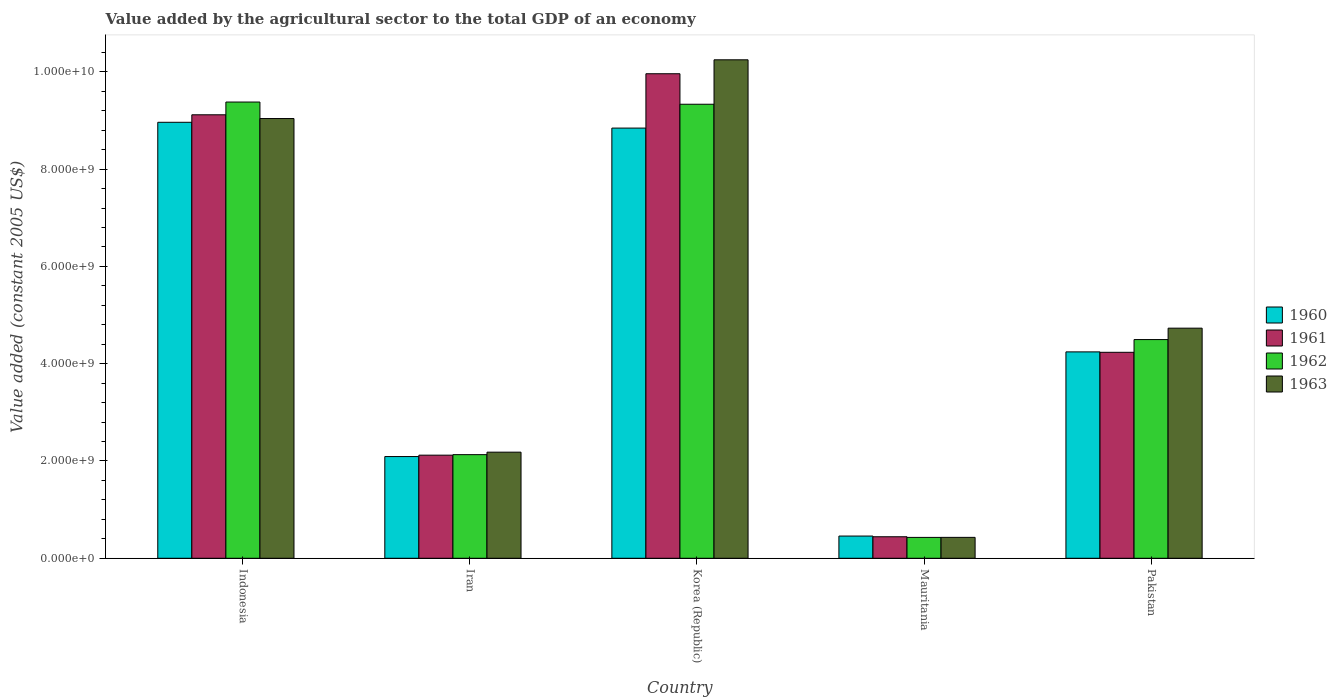How many different coloured bars are there?
Ensure brevity in your answer.  4. How many groups of bars are there?
Provide a succinct answer. 5. How many bars are there on the 5th tick from the left?
Your answer should be compact. 4. How many bars are there on the 2nd tick from the right?
Ensure brevity in your answer.  4. What is the label of the 4th group of bars from the left?
Provide a succinct answer. Mauritania. What is the value added by the agricultural sector in 1960 in Pakistan?
Offer a very short reply. 4.24e+09. Across all countries, what is the maximum value added by the agricultural sector in 1962?
Your answer should be compact. 9.38e+09. Across all countries, what is the minimum value added by the agricultural sector in 1962?
Keep it short and to the point. 4.29e+08. In which country was the value added by the agricultural sector in 1961 maximum?
Keep it short and to the point. Korea (Republic). In which country was the value added by the agricultural sector in 1962 minimum?
Keep it short and to the point. Mauritania. What is the total value added by the agricultural sector in 1962 in the graph?
Your answer should be very brief. 2.58e+1. What is the difference between the value added by the agricultural sector in 1963 in Korea (Republic) and that in Mauritania?
Your answer should be very brief. 9.82e+09. What is the difference between the value added by the agricultural sector in 1962 in Pakistan and the value added by the agricultural sector in 1961 in Iran?
Ensure brevity in your answer.  2.38e+09. What is the average value added by the agricultural sector in 1961 per country?
Make the answer very short. 5.17e+09. What is the difference between the value added by the agricultural sector of/in 1962 and value added by the agricultural sector of/in 1961 in Mauritania?
Make the answer very short. -1.31e+07. What is the ratio of the value added by the agricultural sector in 1960 in Iran to that in Mauritania?
Offer a terse response. 4.58. What is the difference between the highest and the second highest value added by the agricultural sector in 1962?
Offer a terse response. -4.52e+07. What is the difference between the highest and the lowest value added by the agricultural sector in 1960?
Provide a succinct answer. 8.51e+09. In how many countries, is the value added by the agricultural sector in 1963 greater than the average value added by the agricultural sector in 1963 taken over all countries?
Provide a succinct answer. 2. What does the 2nd bar from the right in Iran represents?
Provide a succinct answer. 1962. Are all the bars in the graph horizontal?
Make the answer very short. No. Does the graph contain any zero values?
Provide a short and direct response. No. Does the graph contain grids?
Your answer should be compact. No. How are the legend labels stacked?
Your answer should be compact. Vertical. What is the title of the graph?
Your answer should be very brief. Value added by the agricultural sector to the total GDP of an economy. What is the label or title of the X-axis?
Ensure brevity in your answer.  Country. What is the label or title of the Y-axis?
Your answer should be compact. Value added (constant 2005 US$). What is the Value added (constant 2005 US$) in 1960 in Indonesia?
Your answer should be very brief. 8.96e+09. What is the Value added (constant 2005 US$) of 1961 in Indonesia?
Offer a terse response. 9.12e+09. What is the Value added (constant 2005 US$) of 1962 in Indonesia?
Make the answer very short. 9.38e+09. What is the Value added (constant 2005 US$) of 1963 in Indonesia?
Provide a short and direct response. 9.04e+09. What is the Value added (constant 2005 US$) in 1960 in Iran?
Offer a terse response. 2.09e+09. What is the Value added (constant 2005 US$) in 1961 in Iran?
Make the answer very short. 2.12e+09. What is the Value added (constant 2005 US$) in 1962 in Iran?
Ensure brevity in your answer.  2.13e+09. What is the Value added (constant 2005 US$) in 1963 in Iran?
Ensure brevity in your answer.  2.18e+09. What is the Value added (constant 2005 US$) in 1960 in Korea (Republic)?
Provide a short and direct response. 8.84e+09. What is the Value added (constant 2005 US$) in 1961 in Korea (Republic)?
Give a very brief answer. 9.96e+09. What is the Value added (constant 2005 US$) in 1962 in Korea (Republic)?
Give a very brief answer. 9.33e+09. What is the Value added (constant 2005 US$) in 1963 in Korea (Republic)?
Offer a terse response. 1.02e+1. What is the Value added (constant 2005 US$) in 1960 in Mauritania?
Offer a terse response. 4.57e+08. What is the Value added (constant 2005 US$) in 1961 in Mauritania?
Keep it short and to the point. 4.42e+08. What is the Value added (constant 2005 US$) in 1962 in Mauritania?
Provide a succinct answer. 4.29e+08. What is the Value added (constant 2005 US$) in 1963 in Mauritania?
Make the answer very short. 4.30e+08. What is the Value added (constant 2005 US$) of 1960 in Pakistan?
Provide a succinct answer. 4.24e+09. What is the Value added (constant 2005 US$) in 1961 in Pakistan?
Your answer should be compact. 4.23e+09. What is the Value added (constant 2005 US$) in 1962 in Pakistan?
Provide a succinct answer. 4.50e+09. What is the Value added (constant 2005 US$) of 1963 in Pakistan?
Offer a terse response. 4.73e+09. Across all countries, what is the maximum Value added (constant 2005 US$) in 1960?
Ensure brevity in your answer.  8.96e+09. Across all countries, what is the maximum Value added (constant 2005 US$) in 1961?
Provide a short and direct response. 9.96e+09. Across all countries, what is the maximum Value added (constant 2005 US$) of 1962?
Your answer should be compact. 9.38e+09. Across all countries, what is the maximum Value added (constant 2005 US$) in 1963?
Keep it short and to the point. 1.02e+1. Across all countries, what is the minimum Value added (constant 2005 US$) in 1960?
Offer a very short reply. 4.57e+08. Across all countries, what is the minimum Value added (constant 2005 US$) of 1961?
Offer a terse response. 4.42e+08. Across all countries, what is the minimum Value added (constant 2005 US$) of 1962?
Keep it short and to the point. 4.29e+08. Across all countries, what is the minimum Value added (constant 2005 US$) in 1963?
Offer a very short reply. 4.30e+08. What is the total Value added (constant 2005 US$) of 1960 in the graph?
Provide a short and direct response. 2.46e+1. What is the total Value added (constant 2005 US$) of 1961 in the graph?
Give a very brief answer. 2.59e+1. What is the total Value added (constant 2005 US$) of 1962 in the graph?
Provide a succinct answer. 2.58e+1. What is the total Value added (constant 2005 US$) in 1963 in the graph?
Ensure brevity in your answer.  2.66e+1. What is the difference between the Value added (constant 2005 US$) in 1960 in Indonesia and that in Iran?
Give a very brief answer. 6.87e+09. What is the difference between the Value added (constant 2005 US$) of 1961 in Indonesia and that in Iran?
Provide a short and direct response. 7.00e+09. What is the difference between the Value added (constant 2005 US$) in 1962 in Indonesia and that in Iran?
Ensure brevity in your answer.  7.25e+09. What is the difference between the Value added (constant 2005 US$) of 1963 in Indonesia and that in Iran?
Provide a short and direct response. 6.86e+09. What is the difference between the Value added (constant 2005 US$) of 1960 in Indonesia and that in Korea (Republic)?
Provide a succinct answer. 1.19e+08. What is the difference between the Value added (constant 2005 US$) in 1961 in Indonesia and that in Korea (Republic)?
Your answer should be very brief. -8.44e+08. What is the difference between the Value added (constant 2005 US$) in 1962 in Indonesia and that in Korea (Republic)?
Make the answer very short. 4.52e+07. What is the difference between the Value added (constant 2005 US$) in 1963 in Indonesia and that in Korea (Republic)?
Your answer should be very brief. -1.21e+09. What is the difference between the Value added (constant 2005 US$) in 1960 in Indonesia and that in Mauritania?
Your answer should be very brief. 8.51e+09. What is the difference between the Value added (constant 2005 US$) in 1961 in Indonesia and that in Mauritania?
Make the answer very short. 8.68e+09. What is the difference between the Value added (constant 2005 US$) of 1962 in Indonesia and that in Mauritania?
Your answer should be very brief. 8.95e+09. What is the difference between the Value added (constant 2005 US$) of 1963 in Indonesia and that in Mauritania?
Your response must be concise. 8.61e+09. What is the difference between the Value added (constant 2005 US$) in 1960 in Indonesia and that in Pakistan?
Ensure brevity in your answer.  4.72e+09. What is the difference between the Value added (constant 2005 US$) in 1961 in Indonesia and that in Pakistan?
Offer a terse response. 4.88e+09. What is the difference between the Value added (constant 2005 US$) of 1962 in Indonesia and that in Pakistan?
Your response must be concise. 4.88e+09. What is the difference between the Value added (constant 2005 US$) in 1963 in Indonesia and that in Pakistan?
Give a very brief answer. 4.31e+09. What is the difference between the Value added (constant 2005 US$) of 1960 in Iran and that in Korea (Republic)?
Your answer should be very brief. -6.75e+09. What is the difference between the Value added (constant 2005 US$) in 1961 in Iran and that in Korea (Republic)?
Ensure brevity in your answer.  -7.84e+09. What is the difference between the Value added (constant 2005 US$) in 1962 in Iran and that in Korea (Republic)?
Ensure brevity in your answer.  -7.20e+09. What is the difference between the Value added (constant 2005 US$) in 1963 in Iran and that in Korea (Republic)?
Provide a succinct answer. -8.07e+09. What is the difference between the Value added (constant 2005 US$) in 1960 in Iran and that in Mauritania?
Your response must be concise. 1.63e+09. What is the difference between the Value added (constant 2005 US$) in 1961 in Iran and that in Mauritania?
Provide a short and direct response. 1.68e+09. What is the difference between the Value added (constant 2005 US$) in 1962 in Iran and that in Mauritania?
Offer a terse response. 1.70e+09. What is the difference between the Value added (constant 2005 US$) in 1963 in Iran and that in Mauritania?
Provide a succinct answer. 1.75e+09. What is the difference between the Value added (constant 2005 US$) in 1960 in Iran and that in Pakistan?
Keep it short and to the point. -2.15e+09. What is the difference between the Value added (constant 2005 US$) in 1961 in Iran and that in Pakistan?
Your answer should be very brief. -2.11e+09. What is the difference between the Value added (constant 2005 US$) of 1962 in Iran and that in Pakistan?
Keep it short and to the point. -2.37e+09. What is the difference between the Value added (constant 2005 US$) of 1963 in Iran and that in Pakistan?
Keep it short and to the point. -2.55e+09. What is the difference between the Value added (constant 2005 US$) in 1960 in Korea (Republic) and that in Mauritania?
Offer a terse response. 8.39e+09. What is the difference between the Value added (constant 2005 US$) in 1961 in Korea (Republic) and that in Mauritania?
Offer a terse response. 9.52e+09. What is the difference between the Value added (constant 2005 US$) of 1962 in Korea (Republic) and that in Mauritania?
Keep it short and to the point. 8.91e+09. What is the difference between the Value added (constant 2005 US$) in 1963 in Korea (Republic) and that in Mauritania?
Your answer should be compact. 9.82e+09. What is the difference between the Value added (constant 2005 US$) of 1960 in Korea (Republic) and that in Pakistan?
Ensure brevity in your answer.  4.60e+09. What is the difference between the Value added (constant 2005 US$) in 1961 in Korea (Republic) and that in Pakistan?
Keep it short and to the point. 5.73e+09. What is the difference between the Value added (constant 2005 US$) of 1962 in Korea (Republic) and that in Pakistan?
Provide a succinct answer. 4.84e+09. What is the difference between the Value added (constant 2005 US$) of 1963 in Korea (Republic) and that in Pakistan?
Ensure brevity in your answer.  5.52e+09. What is the difference between the Value added (constant 2005 US$) of 1960 in Mauritania and that in Pakistan?
Give a very brief answer. -3.79e+09. What is the difference between the Value added (constant 2005 US$) in 1961 in Mauritania and that in Pakistan?
Ensure brevity in your answer.  -3.79e+09. What is the difference between the Value added (constant 2005 US$) in 1962 in Mauritania and that in Pakistan?
Offer a terse response. -4.07e+09. What is the difference between the Value added (constant 2005 US$) in 1963 in Mauritania and that in Pakistan?
Your answer should be very brief. -4.30e+09. What is the difference between the Value added (constant 2005 US$) in 1960 in Indonesia and the Value added (constant 2005 US$) in 1961 in Iran?
Offer a very short reply. 6.84e+09. What is the difference between the Value added (constant 2005 US$) in 1960 in Indonesia and the Value added (constant 2005 US$) in 1962 in Iran?
Keep it short and to the point. 6.83e+09. What is the difference between the Value added (constant 2005 US$) of 1960 in Indonesia and the Value added (constant 2005 US$) of 1963 in Iran?
Provide a short and direct response. 6.78e+09. What is the difference between the Value added (constant 2005 US$) of 1961 in Indonesia and the Value added (constant 2005 US$) of 1962 in Iran?
Make the answer very short. 6.99e+09. What is the difference between the Value added (constant 2005 US$) of 1961 in Indonesia and the Value added (constant 2005 US$) of 1963 in Iran?
Keep it short and to the point. 6.94e+09. What is the difference between the Value added (constant 2005 US$) of 1962 in Indonesia and the Value added (constant 2005 US$) of 1963 in Iran?
Keep it short and to the point. 7.20e+09. What is the difference between the Value added (constant 2005 US$) of 1960 in Indonesia and the Value added (constant 2005 US$) of 1961 in Korea (Republic)?
Give a very brief answer. -9.98e+08. What is the difference between the Value added (constant 2005 US$) in 1960 in Indonesia and the Value added (constant 2005 US$) in 1962 in Korea (Republic)?
Your answer should be very brief. -3.71e+08. What is the difference between the Value added (constant 2005 US$) of 1960 in Indonesia and the Value added (constant 2005 US$) of 1963 in Korea (Republic)?
Ensure brevity in your answer.  -1.28e+09. What is the difference between the Value added (constant 2005 US$) of 1961 in Indonesia and the Value added (constant 2005 US$) of 1962 in Korea (Republic)?
Your response must be concise. -2.17e+08. What is the difference between the Value added (constant 2005 US$) of 1961 in Indonesia and the Value added (constant 2005 US$) of 1963 in Korea (Republic)?
Make the answer very short. -1.13e+09. What is the difference between the Value added (constant 2005 US$) in 1962 in Indonesia and the Value added (constant 2005 US$) in 1963 in Korea (Republic)?
Your answer should be very brief. -8.69e+08. What is the difference between the Value added (constant 2005 US$) in 1960 in Indonesia and the Value added (constant 2005 US$) in 1961 in Mauritania?
Offer a terse response. 8.52e+09. What is the difference between the Value added (constant 2005 US$) in 1960 in Indonesia and the Value added (constant 2005 US$) in 1962 in Mauritania?
Your response must be concise. 8.53e+09. What is the difference between the Value added (constant 2005 US$) of 1960 in Indonesia and the Value added (constant 2005 US$) of 1963 in Mauritania?
Your answer should be very brief. 8.53e+09. What is the difference between the Value added (constant 2005 US$) in 1961 in Indonesia and the Value added (constant 2005 US$) in 1962 in Mauritania?
Provide a short and direct response. 8.69e+09. What is the difference between the Value added (constant 2005 US$) in 1961 in Indonesia and the Value added (constant 2005 US$) in 1963 in Mauritania?
Give a very brief answer. 8.69e+09. What is the difference between the Value added (constant 2005 US$) in 1962 in Indonesia and the Value added (constant 2005 US$) in 1963 in Mauritania?
Offer a very short reply. 8.95e+09. What is the difference between the Value added (constant 2005 US$) in 1960 in Indonesia and the Value added (constant 2005 US$) in 1961 in Pakistan?
Your response must be concise. 4.73e+09. What is the difference between the Value added (constant 2005 US$) of 1960 in Indonesia and the Value added (constant 2005 US$) of 1962 in Pakistan?
Your response must be concise. 4.47e+09. What is the difference between the Value added (constant 2005 US$) of 1960 in Indonesia and the Value added (constant 2005 US$) of 1963 in Pakistan?
Offer a very short reply. 4.23e+09. What is the difference between the Value added (constant 2005 US$) in 1961 in Indonesia and the Value added (constant 2005 US$) in 1962 in Pakistan?
Your response must be concise. 4.62e+09. What is the difference between the Value added (constant 2005 US$) of 1961 in Indonesia and the Value added (constant 2005 US$) of 1963 in Pakistan?
Your response must be concise. 4.39e+09. What is the difference between the Value added (constant 2005 US$) of 1962 in Indonesia and the Value added (constant 2005 US$) of 1963 in Pakistan?
Your response must be concise. 4.65e+09. What is the difference between the Value added (constant 2005 US$) of 1960 in Iran and the Value added (constant 2005 US$) of 1961 in Korea (Republic)?
Give a very brief answer. -7.87e+09. What is the difference between the Value added (constant 2005 US$) of 1960 in Iran and the Value added (constant 2005 US$) of 1962 in Korea (Republic)?
Your answer should be very brief. -7.24e+09. What is the difference between the Value added (constant 2005 US$) in 1960 in Iran and the Value added (constant 2005 US$) in 1963 in Korea (Republic)?
Make the answer very short. -8.16e+09. What is the difference between the Value added (constant 2005 US$) in 1961 in Iran and the Value added (constant 2005 US$) in 1962 in Korea (Republic)?
Ensure brevity in your answer.  -7.21e+09. What is the difference between the Value added (constant 2005 US$) of 1961 in Iran and the Value added (constant 2005 US$) of 1963 in Korea (Republic)?
Make the answer very short. -8.13e+09. What is the difference between the Value added (constant 2005 US$) in 1962 in Iran and the Value added (constant 2005 US$) in 1963 in Korea (Republic)?
Offer a terse response. -8.12e+09. What is the difference between the Value added (constant 2005 US$) in 1960 in Iran and the Value added (constant 2005 US$) in 1961 in Mauritania?
Offer a terse response. 1.65e+09. What is the difference between the Value added (constant 2005 US$) in 1960 in Iran and the Value added (constant 2005 US$) in 1962 in Mauritania?
Offer a terse response. 1.66e+09. What is the difference between the Value added (constant 2005 US$) in 1960 in Iran and the Value added (constant 2005 US$) in 1963 in Mauritania?
Your answer should be compact. 1.66e+09. What is the difference between the Value added (constant 2005 US$) in 1961 in Iran and the Value added (constant 2005 US$) in 1962 in Mauritania?
Provide a short and direct response. 1.69e+09. What is the difference between the Value added (constant 2005 US$) in 1961 in Iran and the Value added (constant 2005 US$) in 1963 in Mauritania?
Your response must be concise. 1.69e+09. What is the difference between the Value added (constant 2005 US$) of 1962 in Iran and the Value added (constant 2005 US$) of 1963 in Mauritania?
Keep it short and to the point. 1.70e+09. What is the difference between the Value added (constant 2005 US$) of 1960 in Iran and the Value added (constant 2005 US$) of 1961 in Pakistan?
Offer a terse response. -2.14e+09. What is the difference between the Value added (constant 2005 US$) of 1960 in Iran and the Value added (constant 2005 US$) of 1962 in Pakistan?
Your answer should be very brief. -2.40e+09. What is the difference between the Value added (constant 2005 US$) in 1960 in Iran and the Value added (constant 2005 US$) in 1963 in Pakistan?
Keep it short and to the point. -2.64e+09. What is the difference between the Value added (constant 2005 US$) in 1961 in Iran and the Value added (constant 2005 US$) in 1962 in Pakistan?
Keep it short and to the point. -2.38e+09. What is the difference between the Value added (constant 2005 US$) in 1961 in Iran and the Value added (constant 2005 US$) in 1963 in Pakistan?
Your response must be concise. -2.61e+09. What is the difference between the Value added (constant 2005 US$) of 1962 in Iran and the Value added (constant 2005 US$) of 1963 in Pakistan?
Provide a short and direct response. -2.60e+09. What is the difference between the Value added (constant 2005 US$) in 1960 in Korea (Republic) and the Value added (constant 2005 US$) in 1961 in Mauritania?
Your answer should be compact. 8.40e+09. What is the difference between the Value added (constant 2005 US$) in 1960 in Korea (Republic) and the Value added (constant 2005 US$) in 1962 in Mauritania?
Your answer should be very brief. 8.41e+09. What is the difference between the Value added (constant 2005 US$) of 1960 in Korea (Republic) and the Value added (constant 2005 US$) of 1963 in Mauritania?
Offer a terse response. 8.41e+09. What is the difference between the Value added (constant 2005 US$) of 1961 in Korea (Republic) and the Value added (constant 2005 US$) of 1962 in Mauritania?
Your answer should be very brief. 9.53e+09. What is the difference between the Value added (constant 2005 US$) of 1961 in Korea (Republic) and the Value added (constant 2005 US$) of 1963 in Mauritania?
Give a very brief answer. 9.53e+09. What is the difference between the Value added (constant 2005 US$) in 1962 in Korea (Republic) and the Value added (constant 2005 US$) in 1963 in Mauritania?
Offer a terse response. 8.90e+09. What is the difference between the Value added (constant 2005 US$) of 1960 in Korea (Republic) and the Value added (constant 2005 US$) of 1961 in Pakistan?
Provide a succinct answer. 4.61e+09. What is the difference between the Value added (constant 2005 US$) of 1960 in Korea (Republic) and the Value added (constant 2005 US$) of 1962 in Pakistan?
Make the answer very short. 4.35e+09. What is the difference between the Value added (constant 2005 US$) in 1960 in Korea (Republic) and the Value added (constant 2005 US$) in 1963 in Pakistan?
Ensure brevity in your answer.  4.11e+09. What is the difference between the Value added (constant 2005 US$) of 1961 in Korea (Republic) and the Value added (constant 2005 US$) of 1962 in Pakistan?
Offer a terse response. 5.46e+09. What is the difference between the Value added (constant 2005 US$) of 1961 in Korea (Republic) and the Value added (constant 2005 US$) of 1963 in Pakistan?
Provide a succinct answer. 5.23e+09. What is the difference between the Value added (constant 2005 US$) in 1962 in Korea (Republic) and the Value added (constant 2005 US$) in 1963 in Pakistan?
Your answer should be very brief. 4.60e+09. What is the difference between the Value added (constant 2005 US$) in 1960 in Mauritania and the Value added (constant 2005 US$) in 1961 in Pakistan?
Ensure brevity in your answer.  -3.78e+09. What is the difference between the Value added (constant 2005 US$) in 1960 in Mauritania and the Value added (constant 2005 US$) in 1962 in Pakistan?
Make the answer very short. -4.04e+09. What is the difference between the Value added (constant 2005 US$) of 1960 in Mauritania and the Value added (constant 2005 US$) of 1963 in Pakistan?
Provide a succinct answer. -4.27e+09. What is the difference between the Value added (constant 2005 US$) in 1961 in Mauritania and the Value added (constant 2005 US$) in 1962 in Pakistan?
Keep it short and to the point. -4.05e+09. What is the difference between the Value added (constant 2005 US$) in 1961 in Mauritania and the Value added (constant 2005 US$) in 1963 in Pakistan?
Your answer should be very brief. -4.29e+09. What is the difference between the Value added (constant 2005 US$) of 1962 in Mauritania and the Value added (constant 2005 US$) of 1963 in Pakistan?
Ensure brevity in your answer.  -4.30e+09. What is the average Value added (constant 2005 US$) of 1960 per country?
Make the answer very short. 4.92e+09. What is the average Value added (constant 2005 US$) of 1961 per country?
Offer a very short reply. 5.17e+09. What is the average Value added (constant 2005 US$) of 1962 per country?
Offer a very short reply. 5.15e+09. What is the average Value added (constant 2005 US$) in 1963 per country?
Offer a very short reply. 5.33e+09. What is the difference between the Value added (constant 2005 US$) of 1960 and Value added (constant 2005 US$) of 1961 in Indonesia?
Give a very brief answer. -1.54e+08. What is the difference between the Value added (constant 2005 US$) of 1960 and Value added (constant 2005 US$) of 1962 in Indonesia?
Provide a succinct answer. -4.16e+08. What is the difference between the Value added (constant 2005 US$) in 1960 and Value added (constant 2005 US$) in 1963 in Indonesia?
Your answer should be compact. -7.71e+07. What is the difference between the Value added (constant 2005 US$) in 1961 and Value added (constant 2005 US$) in 1962 in Indonesia?
Your answer should be very brief. -2.62e+08. What is the difference between the Value added (constant 2005 US$) in 1961 and Value added (constant 2005 US$) in 1963 in Indonesia?
Provide a short and direct response. 7.71e+07. What is the difference between the Value added (constant 2005 US$) in 1962 and Value added (constant 2005 US$) in 1963 in Indonesia?
Your answer should be very brief. 3.39e+08. What is the difference between the Value added (constant 2005 US$) of 1960 and Value added (constant 2005 US$) of 1961 in Iran?
Ensure brevity in your answer.  -2.84e+07. What is the difference between the Value added (constant 2005 US$) in 1960 and Value added (constant 2005 US$) in 1962 in Iran?
Provide a short and direct response. -3.89e+07. What is the difference between the Value added (constant 2005 US$) of 1960 and Value added (constant 2005 US$) of 1963 in Iran?
Ensure brevity in your answer.  -9.02e+07. What is the difference between the Value added (constant 2005 US$) of 1961 and Value added (constant 2005 US$) of 1962 in Iran?
Your answer should be compact. -1.05e+07. What is the difference between the Value added (constant 2005 US$) of 1961 and Value added (constant 2005 US$) of 1963 in Iran?
Offer a very short reply. -6.18e+07. What is the difference between the Value added (constant 2005 US$) in 1962 and Value added (constant 2005 US$) in 1963 in Iran?
Keep it short and to the point. -5.13e+07. What is the difference between the Value added (constant 2005 US$) of 1960 and Value added (constant 2005 US$) of 1961 in Korea (Republic)?
Keep it short and to the point. -1.12e+09. What is the difference between the Value added (constant 2005 US$) in 1960 and Value added (constant 2005 US$) in 1962 in Korea (Republic)?
Offer a terse response. -4.90e+08. What is the difference between the Value added (constant 2005 US$) in 1960 and Value added (constant 2005 US$) in 1963 in Korea (Republic)?
Give a very brief answer. -1.40e+09. What is the difference between the Value added (constant 2005 US$) of 1961 and Value added (constant 2005 US$) of 1962 in Korea (Republic)?
Provide a succinct answer. 6.27e+08. What is the difference between the Value added (constant 2005 US$) in 1961 and Value added (constant 2005 US$) in 1963 in Korea (Republic)?
Ensure brevity in your answer.  -2.87e+08. What is the difference between the Value added (constant 2005 US$) in 1962 and Value added (constant 2005 US$) in 1963 in Korea (Republic)?
Offer a terse response. -9.14e+08. What is the difference between the Value added (constant 2005 US$) of 1960 and Value added (constant 2005 US$) of 1961 in Mauritania?
Offer a terse response. 1.44e+07. What is the difference between the Value added (constant 2005 US$) of 1960 and Value added (constant 2005 US$) of 1962 in Mauritania?
Offer a terse response. 2.75e+07. What is the difference between the Value added (constant 2005 US$) in 1960 and Value added (constant 2005 US$) in 1963 in Mauritania?
Your answer should be very brief. 2.68e+07. What is the difference between the Value added (constant 2005 US$) of 1961 and Value added (constant 2005 US$) of 1962 in Mauritania?
Offer a terse response. 1.31e+07. What is the difference between the Value added (constant 2005 US$) of 1961 and Value added (constant 2005 US$) of 1963 in Mauritania?
Your answer should be very brief. 1.24e+07. What is the difference between the Value added (constant 2005 US$) of 1962 and Value added (constant 2005 US$) of 1963 in Mauritania?
Ensure brevity in your answer.  -7.06e+05. What is the difference between the Value added (constant 2005 US$) in 1960 and Value added (constant 2005 US$) in 1961 in Pakistan?
Keep it short and to the point. 8.56e+06. What is the difference between the Value added (constant 2005 US$) in 1960 and Value added (constant 2005 US$) in 1962 in Pakistan?
Ensure brevity in your answer.  -2.53e+08. What is the difference between the Value added (constant 2005 US$) of 1960 and Value added (constant 2005 US$) of 1963 in Pakistan?
Offer a very short reply. -4.87e+08. What is the difference between the Value added (constant 2005 US$) in 1961 and Value added (constant 2005 US$) in 1962 in Pakistan?
Your answer should be compact. -2.62e+08. What is the difference between the Value added (constant 2005 US$) in 1961 and Value added (constant 2005 US$) in 1963 in Pakistan?
Keep it short and to the point. -4.96e+08. What is the difference between the Value added (constant 2005 US$) of 1962 and Value added (constant 2005 US$) of 1963 in Pakistan?
Offer a terse response. -2.34e+08. What is the ratio of the Value added (constant 2005 US$) in 1960 in Indonesia to that in Iran?
Offer a very short reply. 4.29. What is the ratio of the Value added (constant 2005 US$) of 1961 in Indonesia to that in Iran?
Give a very brief answer. 4.3. What is the ratio of the Value added (constant 2005 US$) in 1962 in Indonesia to that in Iran?
Provide a short and direct response. 4.4. What is the ratio of the Value added (constant 2005 US$) in 1963 in Indonesia to that in Iran?
Keep it short and to the point. 4.14. What is the ratio of the Value added (constant 2005 US$) of 1960 in Indonesia to that in Korea (Republic)?
Your answer should be compact. 1.01. What is the ratio of the Value added (constant 2005 US$) in 1961 in Indonesia to that in Korea (Republic)?
Make the answer very short. 0.92. What is the ratio of the Value added (constant 2005 US$) of 1962 in Indonesia to that in Korea (Republic)?
Offer a terse response. 1. What is the ratio of the Value added (constant 2005 US$) of 1963 in Indonesia to that in Korea (Republic)?
Provide a short and direct response. 0.88. What is the ratio of the Value added (constant 2005 US$) of 1960 in Indonesia to that in Mauritania?
Make the answer very short. 19.63. What is the ratio of the Value added (constant 2005 US$) of 1961 in Indonesia to that in Mauritania?
Give a very brief answer. 20.62. What is the ratio of the Value added (constant 2005 US$) in 1962 in Indonesia to that in Mauritania?
Give a very brief answer. 21.86. What is the ratio of the Value added (constant 2005 US$) of 1963 in Indonesia to that in Mauritania?
Your response must be concise. 21.03. What is the ratio of the Value added (constant 2005 US$) in 1960 in Indonesia to that in Pakistan?
Your response must be concise. 2.11. What is the ratio of the Value added (constant 2005 US$) of 1961 in Indonesia to that in Pakistan?
Your answer should be compact. 2.15. What is the ratio of the Value added (constant 2005 US$) in 1962 in Indonesia to that in Pakistan?
Your answer should be compact. 2.09. What is the ratio of the Value added (constant 2005 US$) in 1963 in Indonesia to that in Pakistan?
Give a very brief answer. 1.91. What is the ratio of the Value added (constant 2005 US$) of 1960 in Iran to that in Korea (Republic)?
Your answer should be compact. 0.24. What is the ratio of the Value added (constant 2005 US$) in 1961 in Iran to that in Korea (Republic)?
Offer a very short reply. 0.21. What is the ratio of the Value added (constant 2005 US$) of 1962 in Iran to that in Korea (Republic)?
Offer a very short reply. 0.23. What is the ratio of the Value added (constant 2005 US$) of 1963 in Iran to that in Korea (Republic)?
Your answer should be very brief. 0.21. What is the ratio of the Value added (constant 2005 US$) in 1960 in Iran to that in Mauritania?
Ensure brevity in your answer.  4.58. What is the ratio of the Value added (constant 2005 US$) in 1961 in Iran to that in Mauritania?
Your answer should be very brief. 4.79. What is the ratio of the Value added (constant 2005 US$) of 1962 in Iran to that in Mauritania?
Make the answer very short. 4.96. What is the ratio of the Value added (constant 2005 US$) of 1963 in Iran to that in Mauritania?
Your response must be concise. 5.07. What is the ratio of the Value added (constant 2005 US$) of 1960 in Iran to that in Pakistan?
Make the answer very short. 0.49. What is the ratio of the Value added (constant 2005 US$) of 1961 in Iran to that in Pakistan?
Offer a very short reply. 0.5. What is the ratio of the Value added (constant 2005 US$) in 1962 in Iran to that in Pakistan?
Your answer should be very brief. 0.47. What is the ratio of the Value added (constant 2005 US$) of 1963 in Iran to that in Pakistan?
Your response must be concise. 0.46. What is the ratio of the Value added (constant 2005 US$) in 1960 in Korea (Republic) to that in Mauritania?
Provide a short and direct response. 19.37. What is the ratio of the Value added (constant 2005 US$) in 1961 in Korea (Republic) to that in Mauritania?
Give a very brief answer. 22.52. What is the ratio of the Value added (constant 2005 US$) of 1962 in Korea (Republic) to that in Mauritania?
Ensure brevity in your answer.  21.75. What is the ratio of the Value added (constant 2005 US$) in 1963 in Korea (Republic) to that in Mauritania?
Make the answer very short. 23.84. What is the ratio of the Value added (constant 2005 US$) in 1960 in Korea (Republic) to that in Pakistan?
Ensure brevity in your answer.  2.08. What is the ratio of the Value added (constant 2005 US$) in 1961 in Korea (Republic) to that in Pakistan?
Give a very brief answer. 2.35. What is the ratio of the Value added (constant 2005 US$) of 1962 in Korea (Republic) to that in Pakistan?
Give a very brief answer. 2.08. What is the ratio of the Value added (constant 2005 US$) of 1963 in Korea (Republic) to that in Pakistan?
Offer a terse response. 2.17. What is the ratio of the Value added (constant 2005 US$) of 1960 in Mauritania to that in Pakistan?
Offer a very short reply. 0.11. What is the ratio of the Value added (constant 2005 US$) of 1961 in Mauritania to that in Pakistan?
Offer a terse response. 0.1. What is the ratio of the Value added (constant 2005 US$) in 1962 in Mauritania to that in Pakistan?
Your response must be concise. 0.1. What is the ratio of the Value added (constant 2005 US$) of 1963 in Mauritania to that in Pakistan?
Your response must be concise. 0.09. What is the difference between the highest and the second highest Value added (constant 2005 US$) of 1960?
Your answer should be very brief. 1.19e+08. What is the difference between the highest and the second highest Value added (constant 2005 US$) of 1961?
Give a very brief answer. 8.44e+08. What is the difference between the highest and the second highest Value added (constant 2005 US$) of 1962?
Provide a short and direct response. 4.52e+07. What is the difference between the highest and the second highest Value added (constant 2005 US$) in 1963?
Ensure brevity in your answer.  1.21e+09. What is the difference between the highest and the lowest Value added (constant 2005 US$) of 1960?
Provide a short and direct response. 8.51e+09. What is the difference between the highest and the lowest Value added (constant 2005 US$) in 1961?
Provide a short and direct response. 9.52e+09. What is the difference between the highest and the lowest Value added (constant 2005 US$) in 1962?
Offer a very short reply. 8.95e+09. What is the difference between the highest and the lowest Value added (constant 2005 US$) of 1963?
Provide a short and direct response. 9.82e+09. 